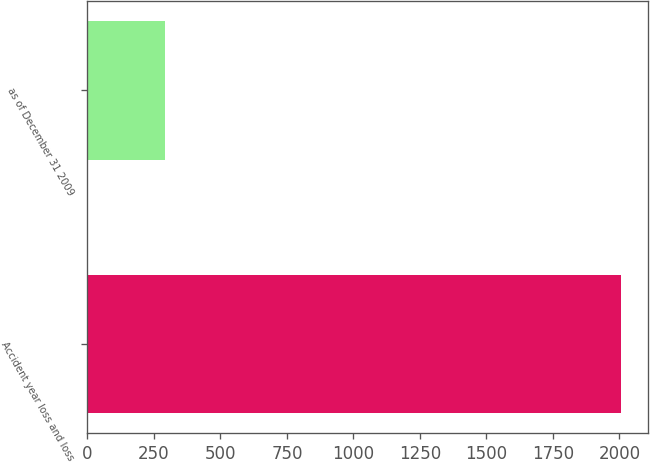<chart> <loc_0><loc_0><loc_500><loc_500><bar_chart><fcel>Accident year loss and loss<fcel>as of December 31 2009<nl><fcel>2007<fcel>293<nl></chart> 